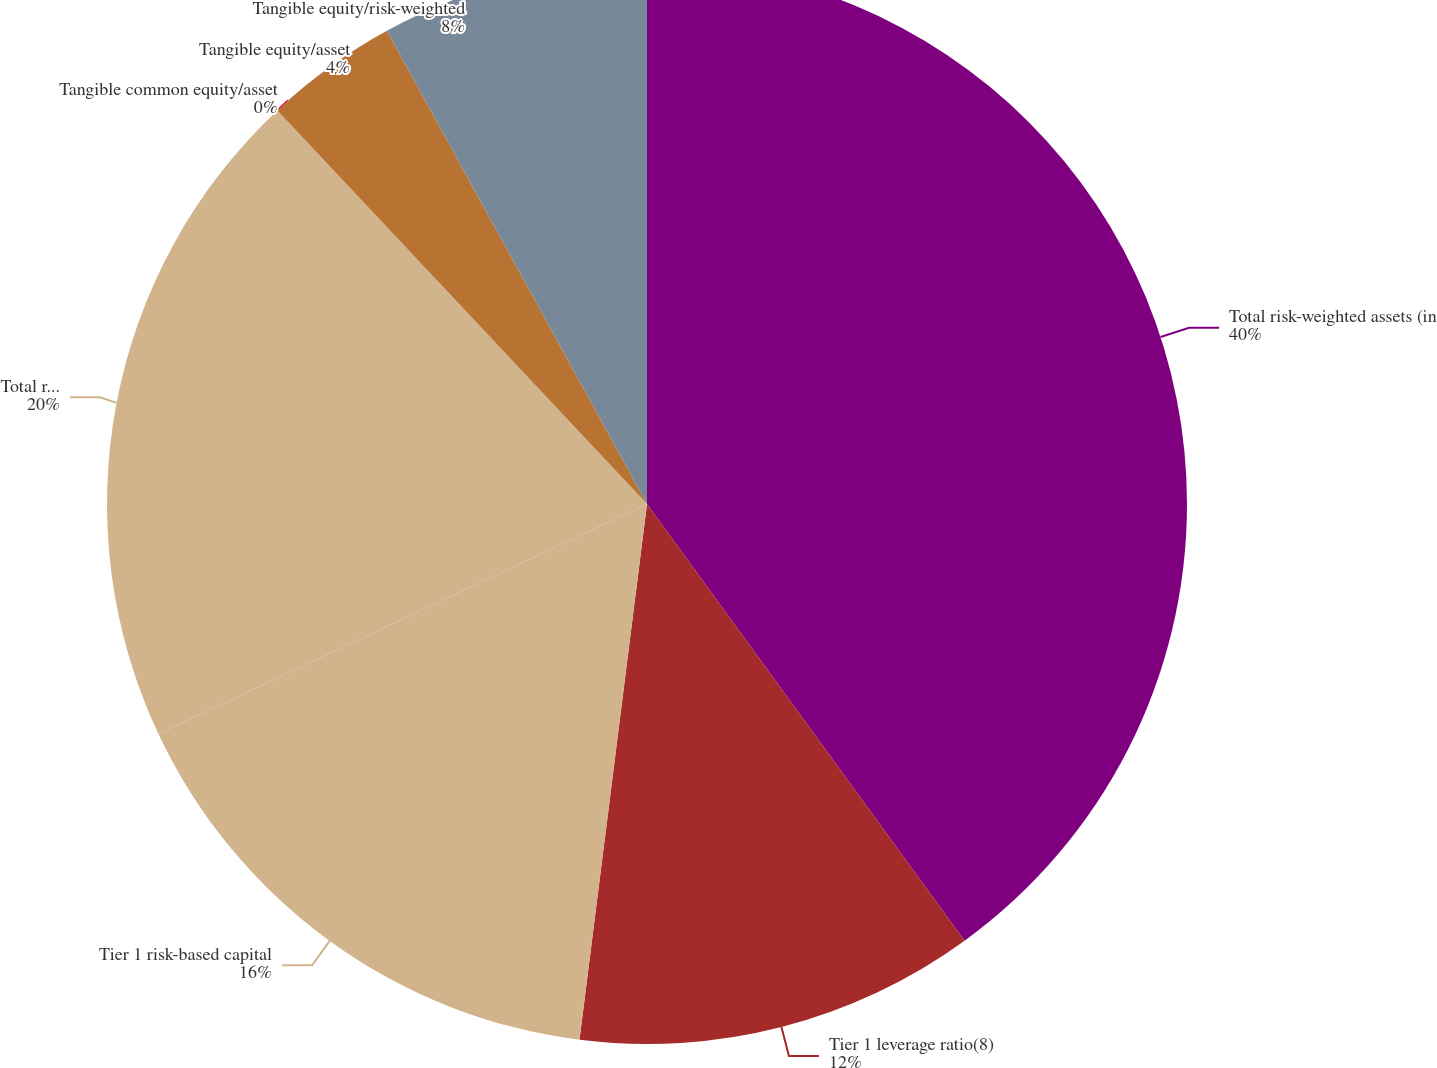<chart> <loc_0><loc_0><loc_500><loc_500><pie_chart><fcel>Total risk-weighted assets (in<fcel>Tier 1 leverage ratio(8)<fcel>Tier 1 risk-based capital<fcel>Total risk-based capital<fcel>Tangible common equity/asset<fcel>Tangible equity/asset<fcel>Tangible equity/risk-weighted<nl><fcel>39.99%<fcel>12.0%<fcel>16.0%<fcel>20.0%<fcel>0.0%<fcel>4.0%<fcel>8.0%<nl></chart> 